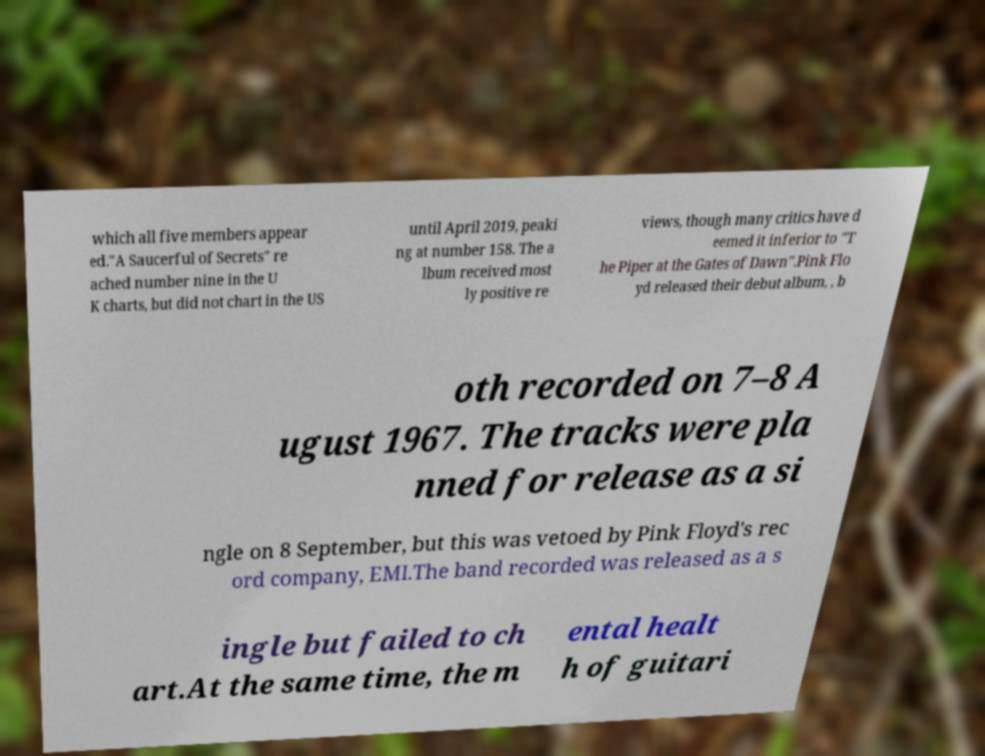Can you read and provide the text displayed in the image?This photo seems to have some interesting text. Can you extract and type it out for me? which all five members appear ed."A Saucerful of Secrets" re ached number nine in the U K charts, but did not chart in the US until April 2019, peaki ng at number 158. The a lbum received most ly positive re views, though many critics have d eemed it inferior to "T he Piper at the Gates of Dawn".Pink Flo yd released their debut album, , b oth recorded on 7–8 A ugust 1967. The tracks were pla nned for release as a si ngle on 8 September, but this was vetoed by Pink Floyd's rec ord company, EMI.The band recorded was released as a s ingle but failed to ch art.At the same time, the m ental healt h of guitari 